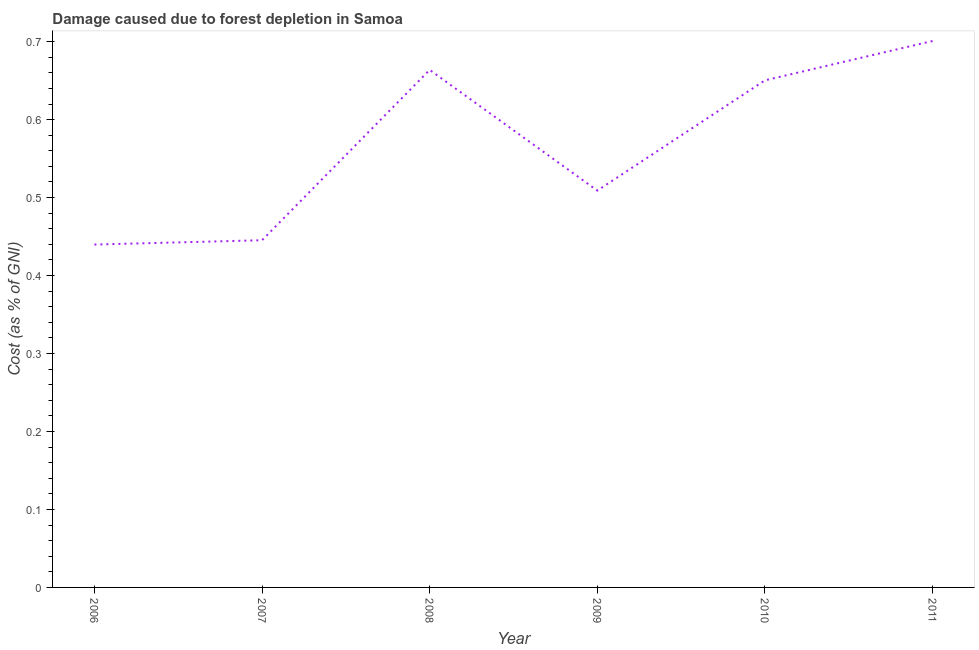What is the damage caused due to forest depletion in 2006?
Offer a terse response. 0.44. Across all years, what is the maximum damage caused due to forest depletion?
Offer a very short reply. 0.7. Across all years, what is the minimum damage caused due to forest depletion?
Make the answer very short. 0.44. What is the sum of the damage caused due to forest depletion?
Your response must be concise. 3.41. What is the difference between the damage caused due to forest depletion in 2007 and 2009?
Your answer should be compact. -0.06. What is the average damage caused due to forest depletion per year?
Ensure brevity in your answer.  0.57. What is the median damage caused due to forest depletion?
Ensure brevity in your answer.  0.58. In how many years, is the damage caused due to forest depletion greater than 0.18 %?
Offer a very short reply. 6. What is the ratio of the damage caused due to forest depletion in 2007 to that in 2011?
Make the answer very short. 0.64. What is the difference between the highest and the second highest damage caused due to forest depletion?
Provide a succinct answer. 0.04. What is the difference between the highest and the lowest damage caused due to forest depletion?
Offer a very short reply. 0.26. In how many years, is the damage caused due to forest depletion greater than the average damage caused due to forest depletion taken over all years?
Your answer should be very brief. 3. Does the damage caused due to forest depletion monotonically increase over the years?
Your answer should be compact. No. How many lines are there?
Provide a short and direct response. 1. Are the values on the major ticks of Y-axis written in scientific E-notation?
Provide a short and direct response. No. Does the graph contain grids?
Your response must be concise. No. What is the title of the graph?
Your response must be concise. Damage caused due to forest depletion in Samoa. What is the label or title of the Y-axis?
Offer a terse response. Cost (as % of GNI). What is the Cost (as % of GNI) in 2006?
Provide a short and direct response. 0.44. What is the Cost (as % of GNI) in 2007?
Ensure brevity in your answer.  0.45. What is the Cost (as % of GNI) of 2008?
Ensure brevity in your answer.  0.66. What is the Cost (as % of GNI) of 2009?
Keep it short and to the point. 0.51. What is the Cost (as % of GNI) of 2010?
Your answer should be compact. 0.65. What is the Cost (as % of GNI) of 2011?
Your answer should be compact. 0.7. What is the difference between the Cost (as % of GNI) in 2006 and 2007?
Make the answer very short. -0.01. What is the difference between the Cost (as % of GNI) in 2006 and 2008?
Give a very brief answer. -0.22. What is the difference between the Cost (as % of GNI) in 2006 and 2009?
Keep it short and to the point. -0.07. What is the difference between the Cost (as % of GNI) in 2006 and 2010?
Provide a succinct answer. -0.21. What is the difference between the Cost (as % of GNI) in 2006 and 2011?
Your answer should be very brief. -0.26. What is the difference between the Cost (as % of GNI) in 2007 and 2008?
Your response must be concise. -0.22. What is the difference between the Cost (as % of GNI) in 2007 and 2009?
Keep it short and to the point. -0.06. What is the difference between the Cost (as % of GNI) in 2007 and 2010?
Your answer should be compact. -0.21. What is the difference between the Cost (as % of GNI) in 2007 and 2011?
Your response must be concise. -0.26. What is the difference between the Cost (as % of GNI) in 2008 and 2009?
Provide a succinct answer. 0.15. What is the difference between the Cost (as % of GNI) in 2008 and 2010?
Offer a very short reply. 0.01. What is the difference between the Cost (as % of GNI) in 2008 and 2011?
Provide a succinct answer. -0.04. What is the difference between the Cost (as % of GNI) in 2009 and 2010?
Make the answer very short. -0.14. What is the difference between the Cost (as % of GNI) in 2009 and 2011?
Provide a short and direct response. -0.19. What is the difference between the Cost (as % of GNI) in 2010 and 2011?
Ensure brevity in your answer.  -0.05. What is the ratio of the Cost (as % of GNI) in 2006 to that in 2007?
Make the answer very short. 0.99. What is the ratio of the Cost (as % of GNI) in 2006 to that in 2008?
Provide a short and direct response. 0.66. What is the ratio of the Cost (as % of GNI) in 2006 to that in 2009?
Ensure brevity in your answer.  0.86. What is the ratio of the Cost (as % of GNI) in 2006 to that in 2010?
Ensure brevity in your answer.  0.68. What is the ratio of the Cost (as % of GNI) in 2006 to that in 2011?
Your answer should be compact. 0.63. What is the ratio of the Cost (as % of GNI) in 2007 to that in 2008?
Ensure brevity in your answer.  0.67. What is the ratio of the Cost (as % of GNI) in 2007 to that in 2010?
Your answer should be compact. 0.69. What is the ratio of the Cost (as % of GNI) in 2007 to that in 2011?
Provide a succinct answer. 0.64. What is the ratio of the Cost (as % of GNI) in 2008 to that in 2009?
Provide a succinct answer. 1.3. What is the ratio of the Cost (as % of GNI) in 2008 to that in 2010?
Your response must be concise. 1.02. What is the ratio of the Cost (as % of GNI) in 2008 to that in 2011?
Provide a succinct answer. 0.95. What is the ratio of the Cost (as % of GNI) in 2009 to that in 2010?
Make the answer very short. 0.78. What is the ratio of the Cost (as % of GNI) in 2009 to that in 2011?
Give a very brief answer. 0.73. What is the ratio of the Cost (as % of GNI) in 2010 to that in 2011?
Keep it short and to the point. 0.93. 